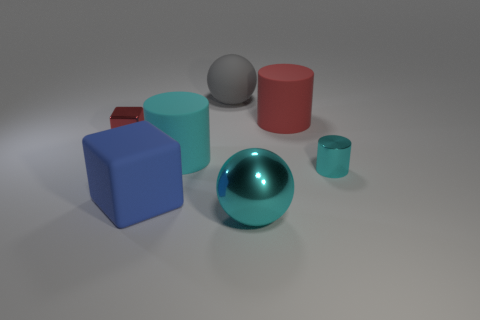Subtract all blue cylinders. Subtract all red balls. How many cylinders are left? 3 Add 2 cylinders. How many objects exist? 9 Subtract all cylinders. How many objects are left? 4 Add 4 large cyan shiny spheres. How many large cyan shiny spheres exist? 5 Subtract 0 cyan cubes. How many objects are left? 7 Subtract all large metallic things. Subtract all tiny red rubber blocks. How many objects are left? 6 Add 7 cyan cylinders. How many cyan cylinders are left? 9 